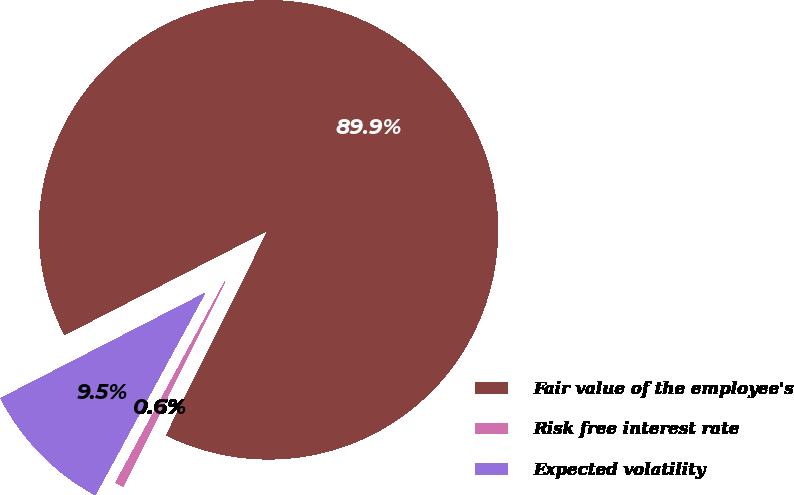Convert chart. <chart><loc_0><loc_0><loc_500><loc_500><pie_chart><fcel>Fair value of the employee's<fcel>Risk free interest rate<fcel>Expected volatility<nl><fcel>89.9%<fcel>0.58%<fcel>9.52%<nl></chart> 